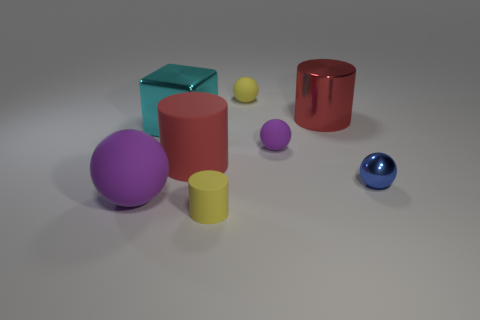Subtract 1 spheres. How many spheres are left? 3 Subtract all blue balls. Subtract all gray cylinders. How many balls are left? 3 Add 2 red things. How many objects exist? 10 Subtract all cylinders. How many objects are left? 5 Subtract 0 brown balls. How many objects are left? 8 Subtract all large red rubber things. Subtract all red cylinders. How many objects are left? 5 Add 5 small blue shiny objects. How many small blue shiny objects are left? 6 Add 7 metallic cylinders. How many metallic cylinders exist? 8 